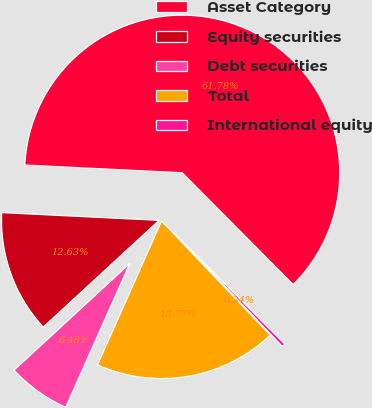Convert chart to OTSL. <chart><loc_0><loc_0><loc_500><loc_500><pie_chart><fcel>Asset Category<fcel>Equity securities<fcel>Debt securities<fcel>Total<fcel>International equity<nl><fcel>61.78%<fcel>12.63%<fcel>6.48%<fcel>18.77%<fcel>0.34%<nl></chart> 